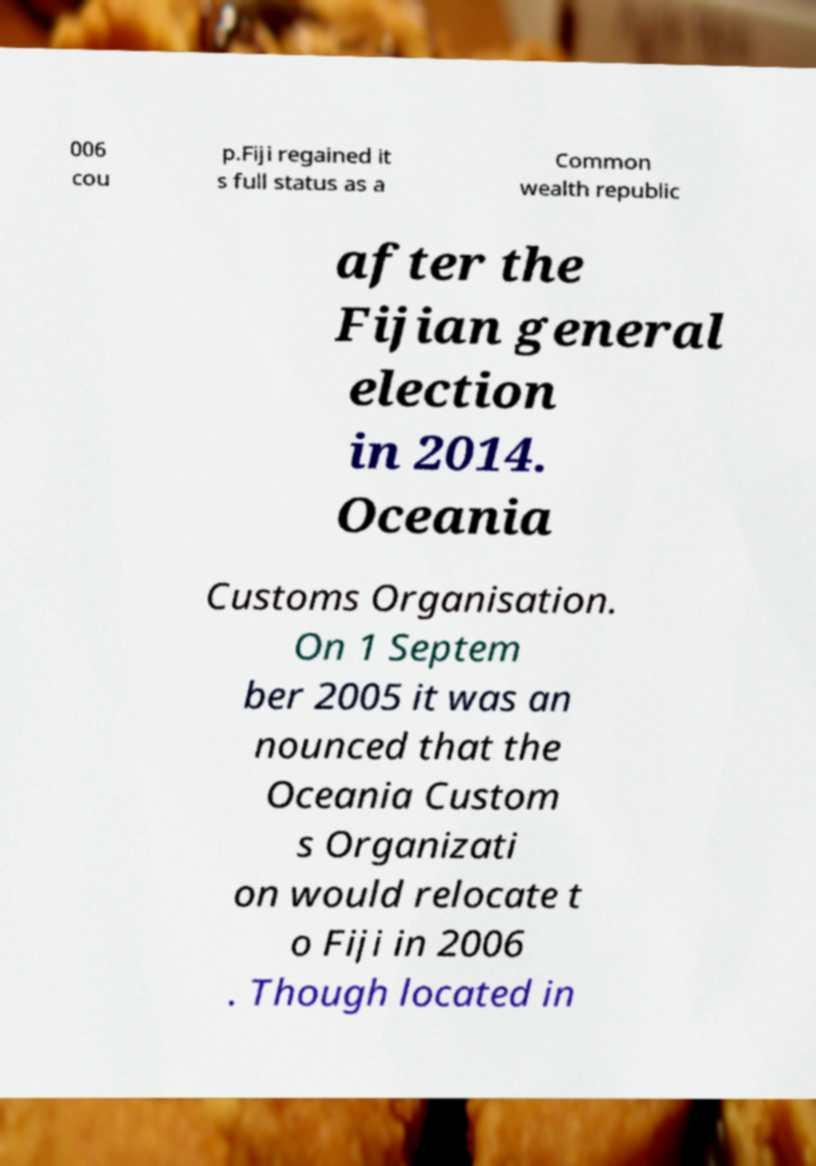Please read and relay the text visible in this image. What does it say? 006 cou p.Fiji regained it s full status as a Common wealth republic after the Fijian general election in 2014. Oceania Customs Organisation. On 1 Septem ber 2005 it was an nounced that the Oceania Custom s Organizati on would relocate t o Fiji in 2006 . Though located in 